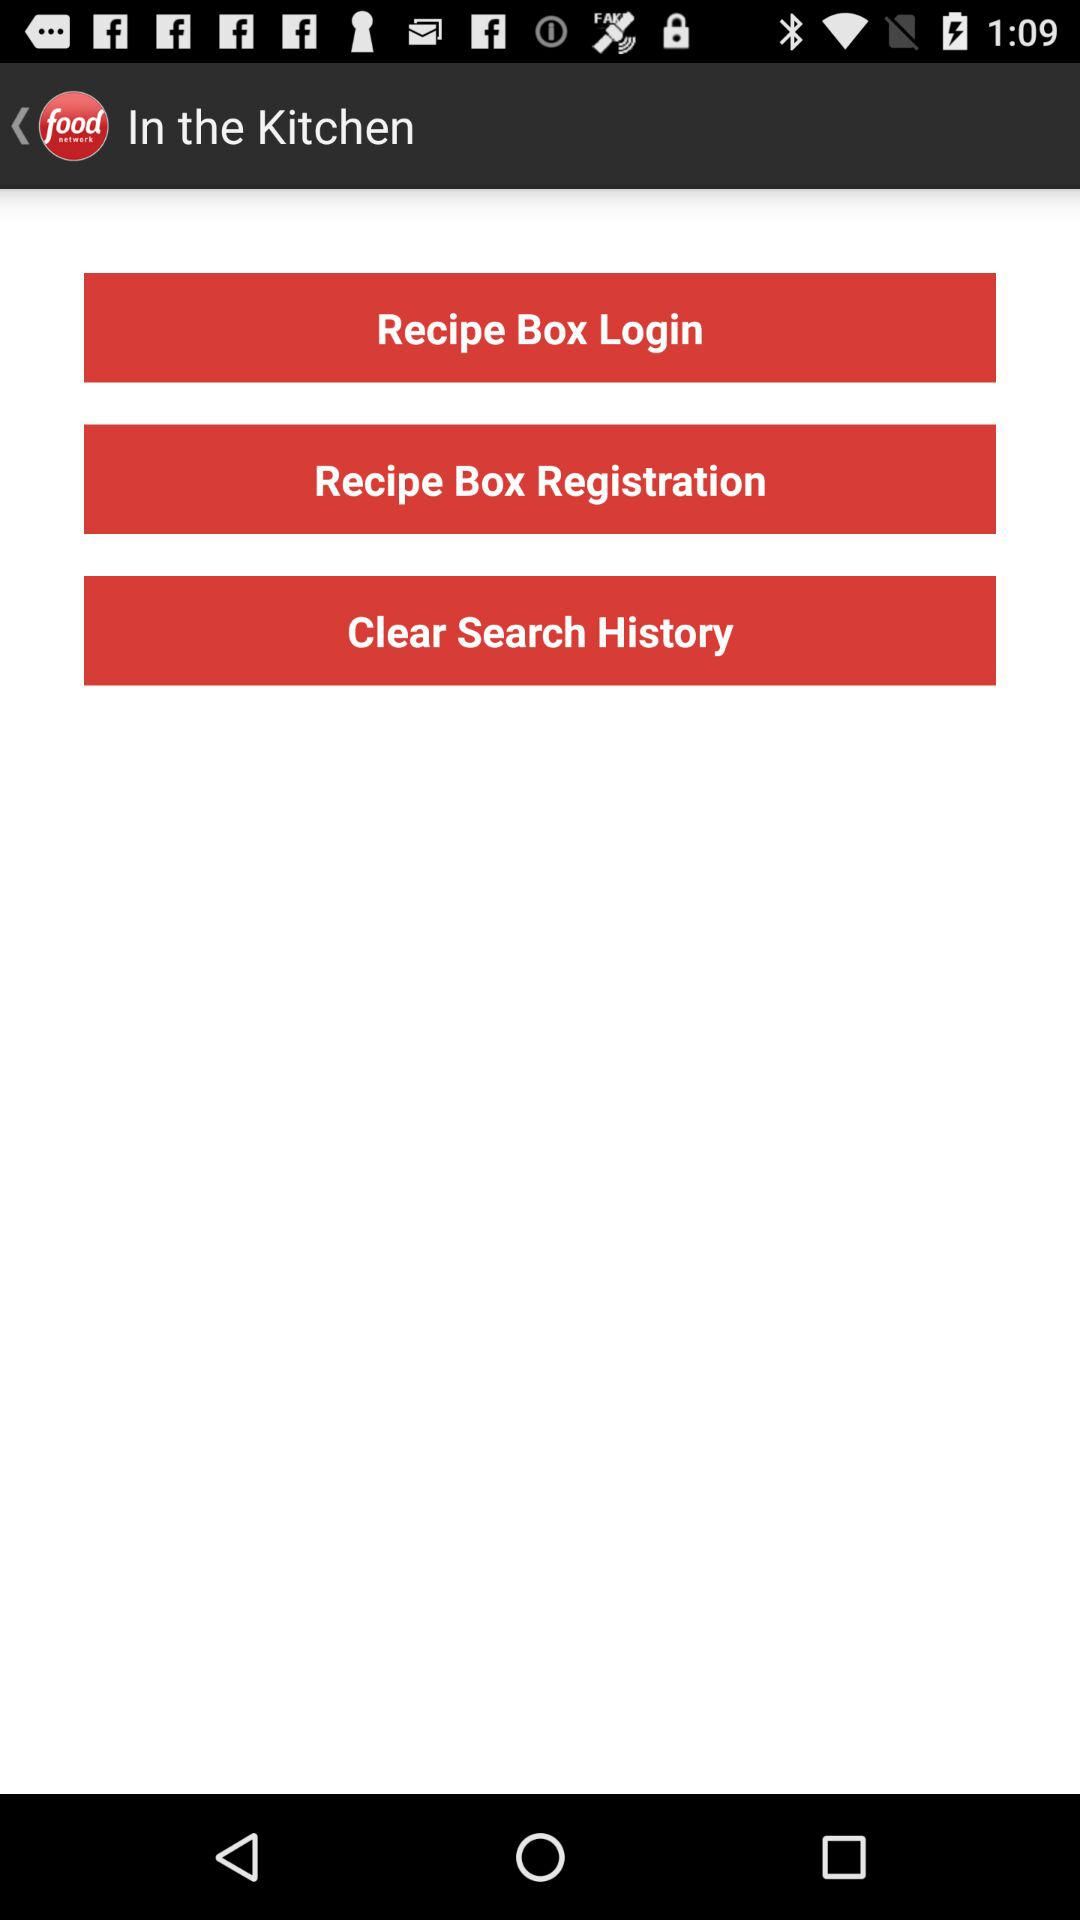What is the name of the application? The name of the application is "Food Network". 